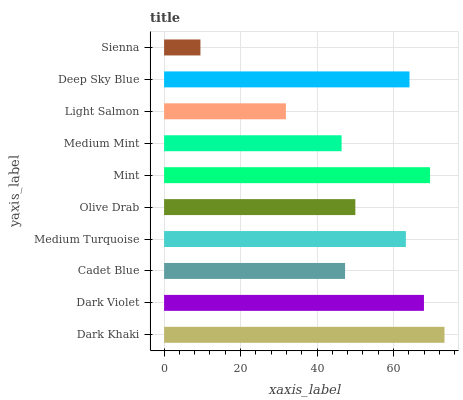Is Sienna the minimum?
Answer yes or no. Yes. Is Dark Khaki the maximum?
Answer yes or no. Yes. Is Dark Violet the minimum?
Answer yes or no. No. Is Dark Violet the maximum?
Answer yes or no. No. Is Dark Khaki greater than Dark Violet?
Answer yes or no. Yes. Is Dark Violet less than Dark Khaki?
Answer yes or no. Yes. Is Dark Violet greater than Dark Khaki?
Answer yes or no. No. Is Dark Khaki less than Dark Violet?
Answer yes or no. No. Is Medium Turquoise the high median?
Answer yes or no. Yes. Is Olive Drab the low median?
Answer yes or no. Yes. Is Deep Sky Blue the high median?
Answer yes or no. No. Is Sienna the low median?
Answer yes or no. No. 